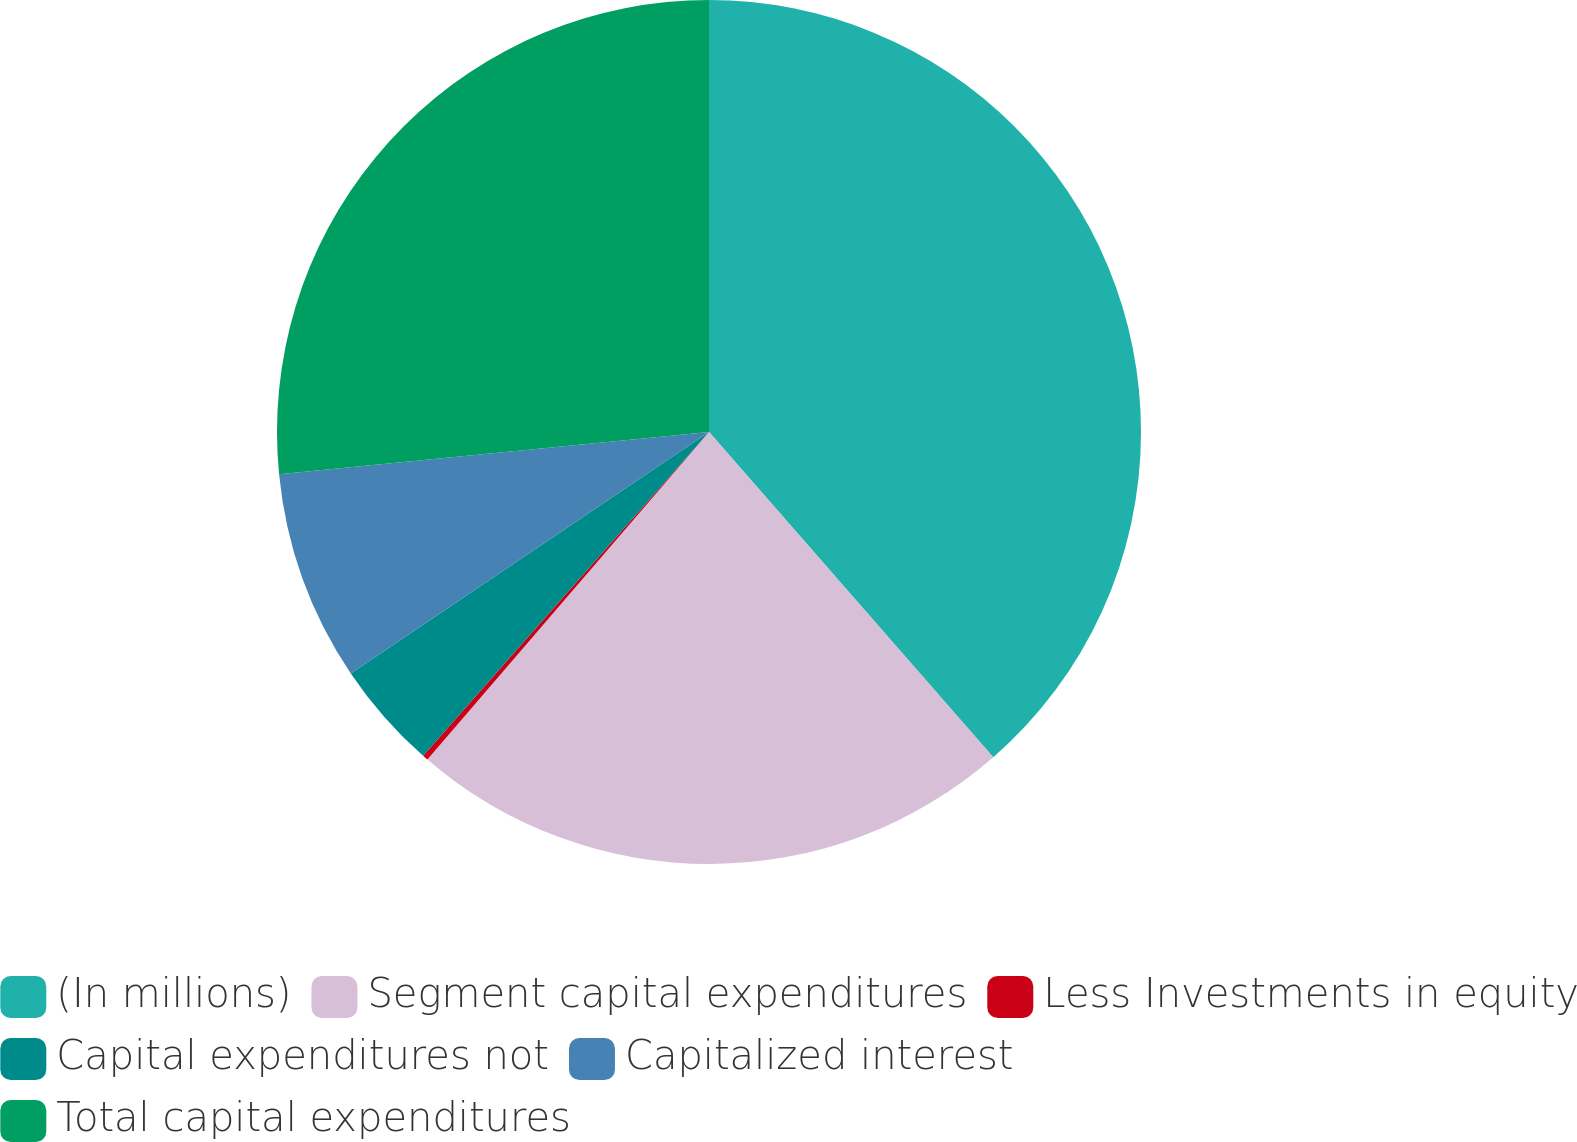Convert chart. <chart><loc_0><loc_0><loc_500><loc_500><pie_chart><fcel>(In millions)<fcel>Segment capital expenditures<fcel>Less Investments in equity<fcel>Capital expenditures not<fcel>Capitalized interest<fcel>Total capital expenditures<nl><fcel>38.57%<fcel>22.73%<fcel>0.21%<fcel>4.05%<fcel>7.88%<fcel>26.56%<nl></chart> 